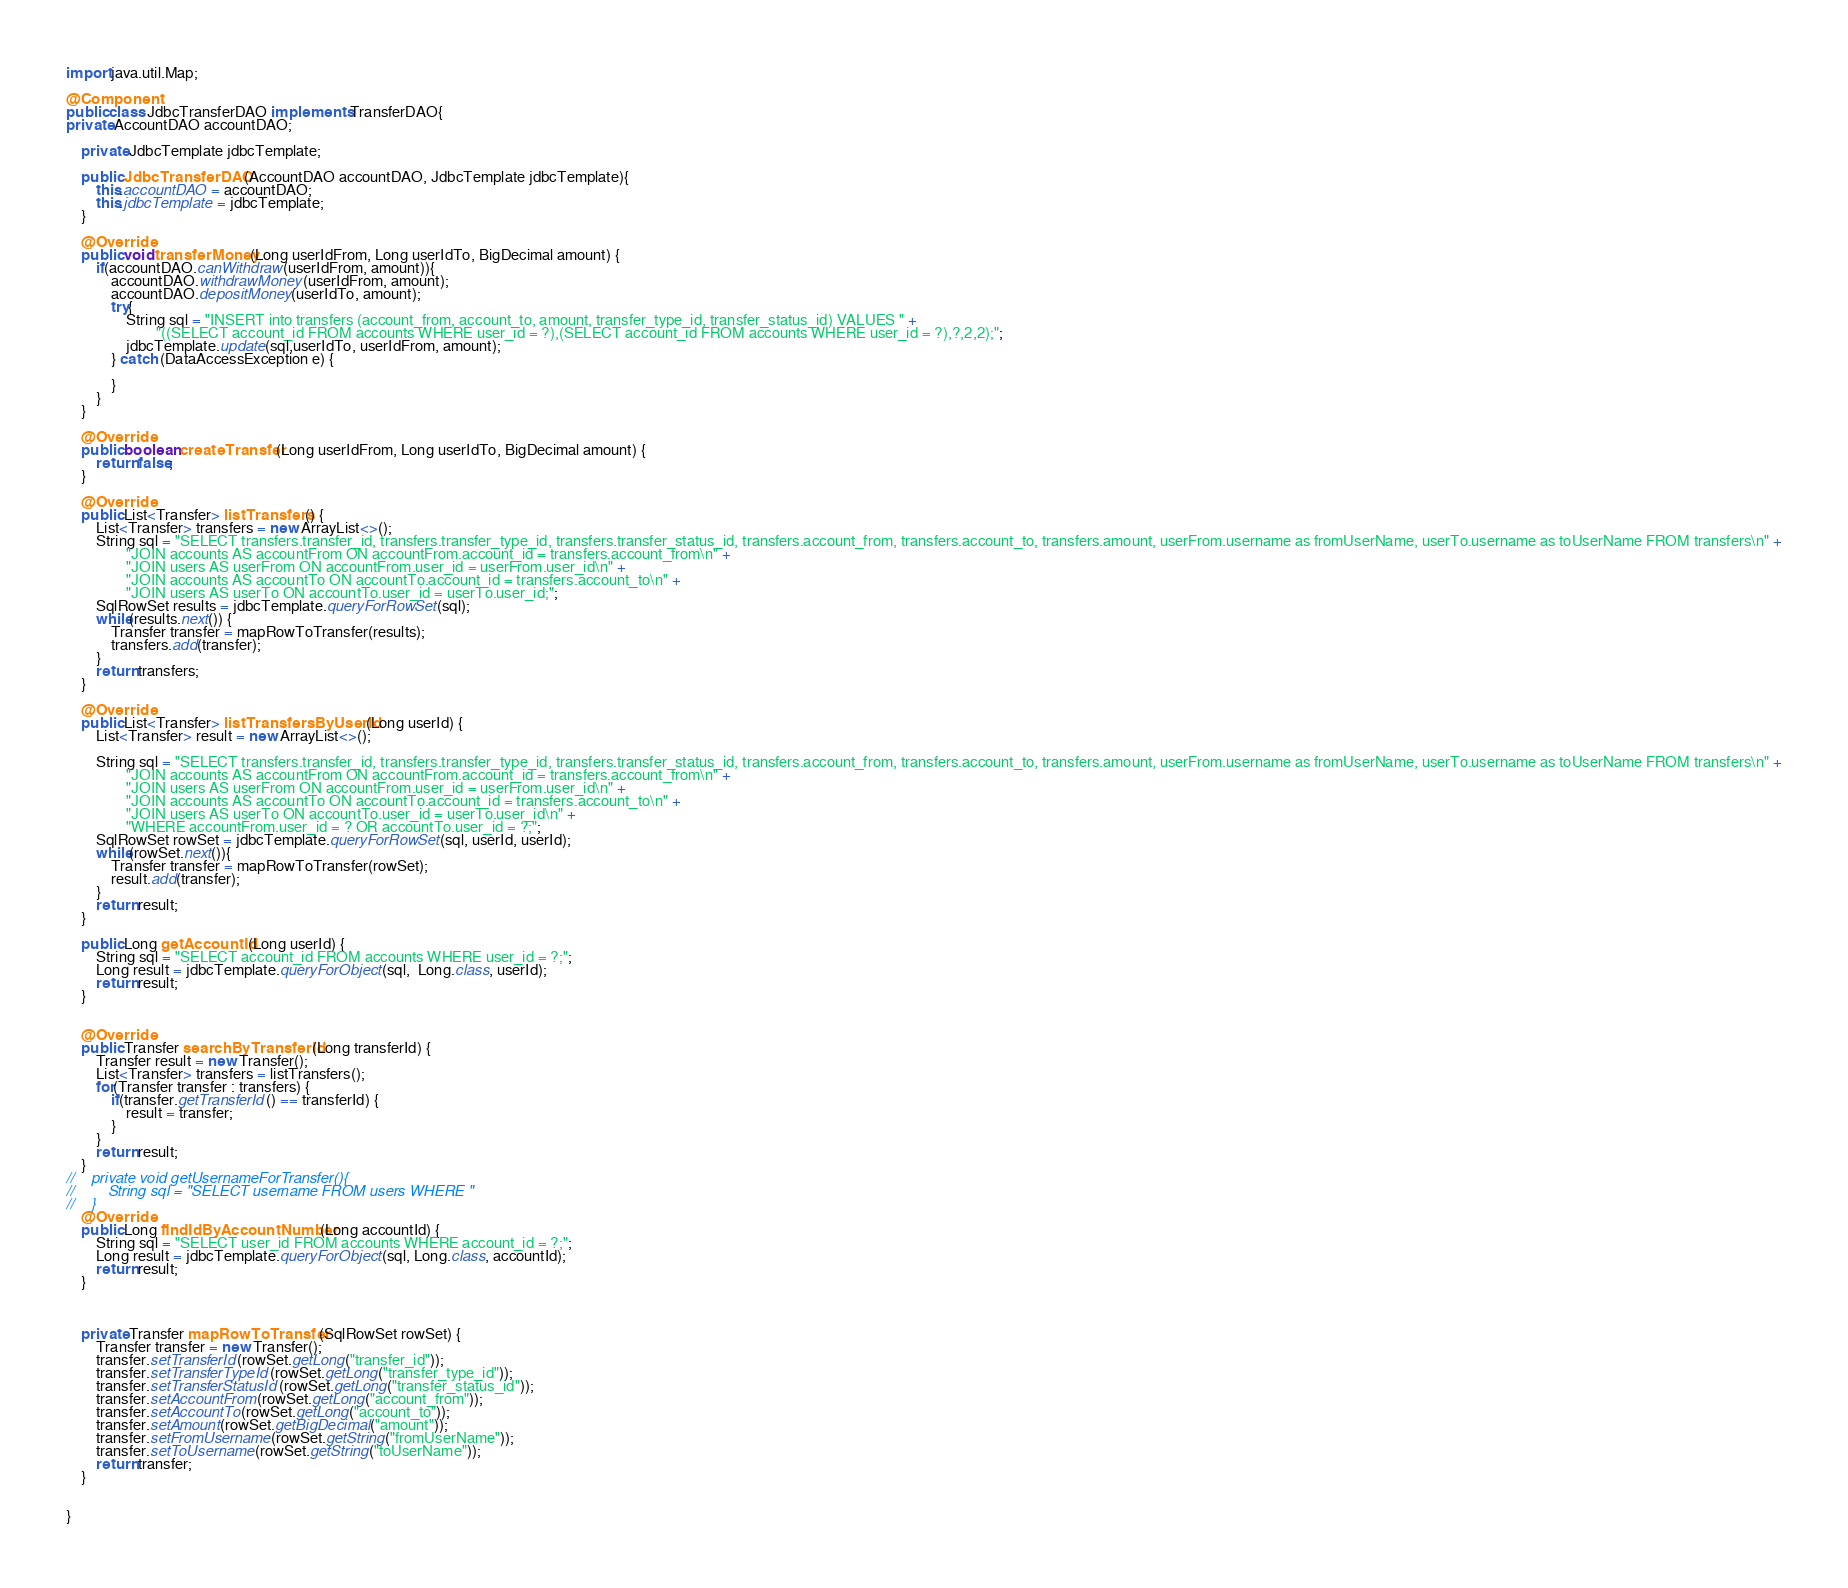<code> <loc_0><loc_0><loc_500><loc_500><_Java_>import java.util.Map;

@Component
public class JdbcTransferDAO implements TransferDAO{
private AccountDAO accountDAO;

    private JdbcTemplate jdbcTemplate;

    public JdbcTransferDAO(AccountDAO accountDAO, JdbcTemplate jdbcTemplate){
        this.accountDAO = accountDAO;
        this.jdbcTemplate = jdbcTemplate;
    }

    @Override
    public void transferMoney(Long userIdFrom, Long userIdTo, BigDecimal amount) {
        if(accountDAO.canWithdraw(userIdFrom, amount)){
            accountDAO.withdrawMoney(userIdFrom, amount);
            accountDAO.depositMoney(userIdTo, amount);
            try{
                String sql = "INSERT into transfers (account_from, account_to, amount, transfer_type_id, transfer_status_id) VALUES " +
                        "((SELECT account_id FROM accounts WHERE user_id = ?),(SELECT account_id FROM accounts WHERE user_id = ?),?,2,2);";
                jdbcTemplate.update(sql,userIdTo, userIdFrom, amount);
            } catch (DataAccessException e) {

            }
        }
    }

    @Override
    public boolean createTransfer(Long userIdFrom, Long userIdTo, BigDecimal amount) {
        return false;
    }

    @Override
    public List<Transfer> listTransfers() {
        List<Transfer> transfers = new ArrayList<>();
        String sql = "SELECT transfers.transfer_id, transfers.transfer_type_id, transfers.transfer_status_id, transfers.account_from, transfers.account_to, transfers.amount, userFrom.username as fromUserName, userTo.username as toUserName FROM transfers\n" +
                "JOIN accounts AS accountFrom ON accountFrom.account_id = transfers.account_from\n" +
                "JOIN users AS userFrom ON accountFrom.user_id = userFrom.user_id\n" +
                "JOIN accounts AS accountTo ON accountTo.account_id = transfers.account_to\n" +
                "JOIN users AS userTo ON accountTo.user_id = userTo.user_id;";
        SqlRowSet results = jdbcTemplate.queryForRowSet(sql);
        while(results.next()) {
            Transfer transfer = mapRowToTransfer(results);
            transfers.add(transfer);
        }
        return transfers;
    }

    @Override
    public List<Transfer> listTransfersByUserId(Long userId) {
        List<Transfer> result = new ArrayList<>();

        String sql = "SELECT transfers.transfer_id, transfers.transfer_type_id, transfers.transfer_status_id, transfers.account_from, transfers.account_to, transfers.amount, userFrom.username as fromUserName, userTo.username as toUserName FROM transfers\n" +
                "JOIN accounts AS accountFrom ON accountFrom.account_id = transfers.account_from\n" +
                "JOIN users AS userFrom ON accountFrom.user_id = userFrom.user_id\n" +
                "JOIN accounts AS accountTo ON accountTo.account_id = transfers.account_to\n" +
                "JOIN users AS userTo ON accountTo.user_id = userTo.user_id\n" +
                "WHERE accountFrom.user_id = ? OR accountTo.user_id = ?;";
        SqlRowSet rowSet = jdbcTemplate.queryForRowSet(sql, userId, userId);
        while(rowSet.next()){
            Transfer transfer = mapRowToTransfer(rowSet);
            result.add(transfer);
        }
        return result;
    }

    public Long getAccountId(Long userId) {
        String sql = "SELECT account_id FROM accounts WHERE user_id = ?;";
        Long result = jdbcTemplate.queryForObject(sql,  Long.class, userId);
        return result;
    }


    @Override
    public Transfer searchByTransferId(Long transferId) {
        Transfer result = new Transfer();
        List<Transfer> transfers = listTransfers();
        for(Transfer transfer : transfers) {
            if(transfer.getTransferId() == transferId) {
                result = transfer;
            }
        }
        return result;
    }
//    private void getUsernameForTransfer(){
//        String sql = "SELECT username FROM users WHERE "
//    }
    @Override
    public Long findIdByAccountNumber(Long accountId) {
        String sql = "SELECT user_id FROM accounts WHERE account_id = ?;";
        Long result = jdbcTemplate.queryForObject(sql, Long.class, accountId);
        return result;
    }



    private Transfer mapRowToTransfer(SqlRowSet rowSet) {
        Transfer transfer = new Transfer();
        transfer.setTransferId(rowSet.getLong("transfer_id"));
        transfer.setTransferTypeId(rowSet.getLong("transfer_type_id"));
        transfer.setTransferStatusId(rowSet.getLong("transfer_status_id"));
        transfer.setAccountFrom(rowSet.getLong("account_from"));
        transfer.setAccountTo(rowSet.getLong("account_to"));
        transfer.setAmount(rowSet.getBigDecimal("amount"));
        transfer.setFromUsername(rowSet.getString("fromUserName"));
        transfer.setToUsername(rowSet.getString("toUserName"));
        return transfer;
    }


}
</code> 